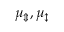<formula> <loc_0><loc_0><loc_500><loc_500>\mu _ { \Updownarrow } , \mu _ { \updownarrow }</formula> 